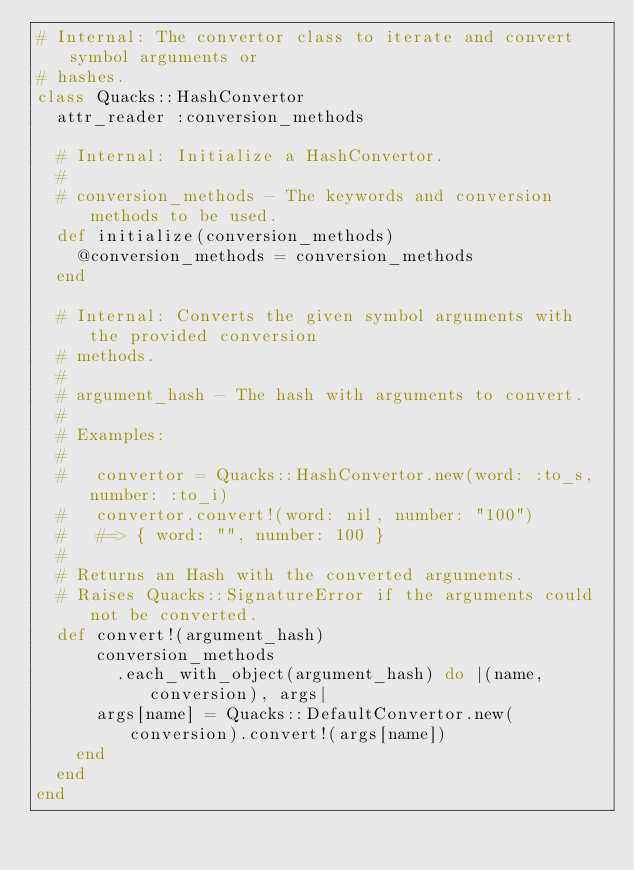Convert code to text. <code><loc_0><loc_0><loc_500><loc_500><_Ruby_># Internal: The convertor class to iterate and convert symbol arguments or
# hashes.
class Quacks::HashConvertor
  attr_reader :conversion_methods

  # Internal: Initialize a HashConvertor.
  #
  # conversion_methods - The keywords and conversion methods to be used.
  def initialize(conversion_methods)
    @conversion_methods = conversion_methods
  end

  # Internal: Converts the given symbol arguments with the provided conversion
  # methods.
  #
  # argument_hash - The hash with arguments to convert.
  #
  # Examples:
  #
  #   convertor = Quacks::HashConvertor.new(word: :to_s, number: :to_i)
  #   convertor.convert!(word: nil, number: "100")
  #   #=> { word: "", number: 100 }
  #
  # Returns an Hash with the converted arguments.
  # Raises Quacks::SignatureError if the arguments could not be converted.
  def convert!(argument_hash)
      conversion_methods
        .each_with_object(argument_hash) do |(name, conversion), args|
      args[name] = Quacks::DefaultConvertor.new(conversion).convert!(args[name])
    end
  end
end
</code> 